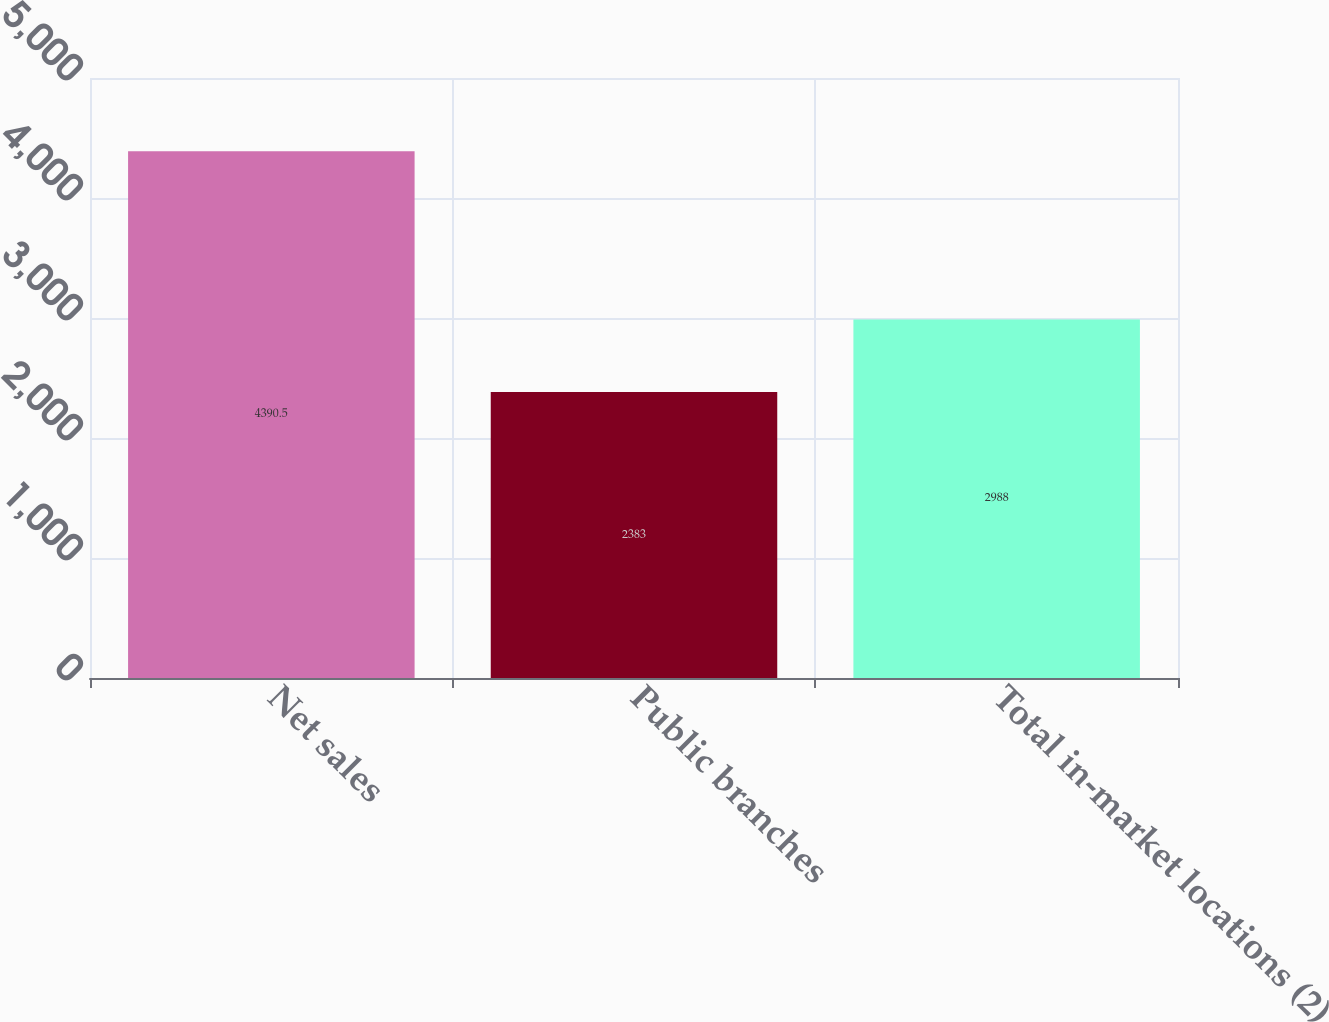Convert chart. <chart><loc_0><loc_0><loc_500><loc_500><bar_chart><fcel>Net sales<fcel>Public branches<fcel>Total in-market locations (2)<nl><fcel>4390.5<fcel>2383<fcel>2988<nl></chart> 